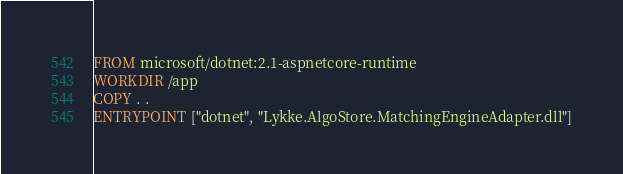Convert code to text. <code><loc_0><loc_0><loc_500><loc_500><_Dockerfile_>FROM microsoft/dotnet:2.1-aspnetcore-runtime
WORKDIR /app
COPY . .
ENTRYPOINT ["dotnet", "Lykke.AlgoStore.MatchingEngineAdapter.dll"]
</code> 